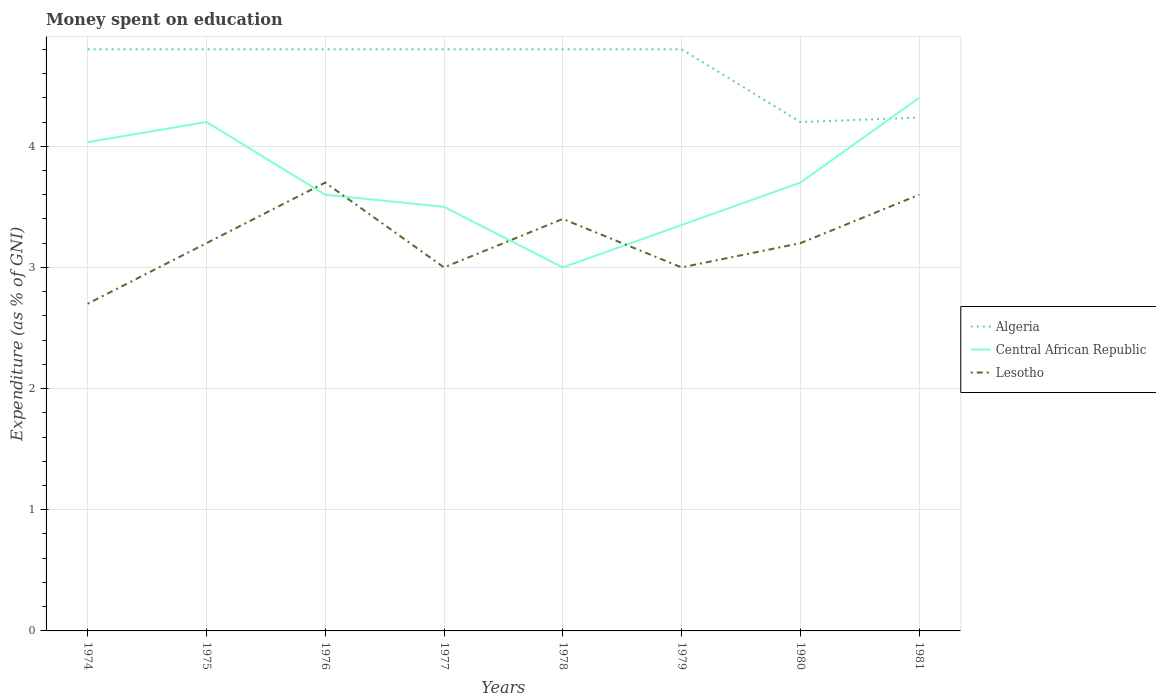How many different coloured lines are there?
Your answer should be compact. 3. Does the line corresponding to Central African Republic intersect with the line corresponding to Algeria?
Ensure brevity in your answer.  Yes. Is the number of lines equal to the number of legend labels?
Offer a terse response. Yes. Across all years, what is the maximum amount of money spent on education in Algeria?
Offer a terse response. 4.2. In which year was the amount of money spent on education in Lesotho maximum?
Keep it short and to the point. 1974. What is the total amount of money spent on education in Central African Republic in the graph?
Ensure brevity in your answer.  0.1. What is the difference between the highest and the second highest amount of money spent on education in Algeria?
Ensure brevity in your answer.  0.6. What is the difference between the highest and the lowest amount of money spent on education in Central African Republic?
Your answer should be very brief. 3. Is the amount of money spent on education in Algeria strictly greater than the amount of money spent on education in Central African Republic over the years?
Make the answer very short. No. Where does the legend appear in the graph?
Ensure brevity in your answer.  Center right. How many legend labels are there?
Give a very brief answer. 3. What is the title of the graph?
Provide a short and direct response. Money spent on education. What is the label or title of the Y-axis?
Offer a very short reply. Expenditure (as % of GNI). What is the Expenditure (as % of GNI) in Algeria in 1974?
Your response must be concise. 4.8. What is the Expenditure (as % of GNI) in Central African Republic in 1974?
Offer a very short reply. 4.03. What is the Expenditure (as % of GNI) in Lesotho in 1974?
Ensure brevity in your answer.  2.7. What is the Expenditure (as % of GNI) of Central African Republic in 1975?
Keep it short and to the point. 4.2. What is the Expenditure (as % of GNI) in Lesotho in 1975?
Give a very brief answer. 3.2. What is the Expenditure (as % of GNI) in Algeria in 1976?
Provide a short and direct response. 4.8. What is the Expenditure (as % of GNI) of Central African Republic in 1976?
Ensure brevity in your answer.  3.6. What is the Expenditure (as % of GNI) in Lesotho in 1976?
Offer a very short reply. 3.7. What is the Expenditure (as % of GNI) in Algeria in 1977?
Offer a very short reply. 4.8. What is the Expenditure (as % of GNI) in Lesotho in 1977?
Ensure brevity in your answer.  3. What is the Expenditure (as % of GNI) of Central African Republic in 1978?
Your response must be concise. 3. What is the Expenditure (as % of GNI) of Lesotho in 1978?
Make the answer very short. 3.4. What is the Expenditure (as % of GNI) in Central African Republic in 1979?
Offer a very short reply. 3.35. What is the Expenditure (as % of GNI) in Lesotho in 1979?
Ensure brevity in your answer.  3. What is the Expenditure (as % of GNI) of Central African Republic in 1980?
Your response must be concise. 3.7. What is the Expenditure (as % of GNI) in Algeria in 1981?
Your answer should be compact. 4.24. What is the Expenditure (as % of GNI) in Lesotho in 1981?
Keep it short and to the point. 3.6. Across all years, what is the maximum Expenditure (as % of GNI) in Lesotho?
Keep it short and to the point. 3.7. Across all years, what is the minimum Expenditure (as % of GNI) in Algeria?
Your answer should be compact. 4.2. Across all years, what is the minimum Expenditure (as % of GNI) in Lesotho?
Your answer should be very brief. 2.7. What is the total Expenditure (as % of GNI) in Algeria in the graph?
Provide a short and direct response. 37.24. What is the total Expenditure (as % of GNI) of Central African Republic in the graph?
Ensure brevity in your answer.  29.78. What is the total Expenditure (as % of GNI) of Lesotho in the graph?
Provide a succinct answer. 25.8. What is the difference between the Expenditure (as % of GNI) of Lesotho in 1974 and that in 1975?
Ensure brevity in your answer.  -0.5. What is the difference between the Expenditure (as % of GNI) of Algeria in 1974 and that in 1976?
Your answer should be very brief. 0. What is the difference between the Expenditure (as % of GNI) in Central African Republic in 1974 and that in 1976?
Your response must be concise. 0.43. What is the difference between the Expenditure (as % of GNI) in Algeria in 1974 and that in 1977?
Provide a succinct answer. 0. What is the difference between the Expenditure (as % of GNI) in Central African Republic in 1974 and that in 1977?
Your answer should be very brief. 0.53. What is the difference between the Expenditure (as % of GNI) in Lesotho in 1974 and that in 1977?
Provide a short and direct response. -0.3. What is the difference between the Expenditure (as % of GNI) of Lesotho in 1974 and that in 1978?
Ensure brevity in your answer.  -0.7. What is the difference between the Expenditure (as % of GNI) in Algeria in 1974 and that in 1979?
Provide a short and direct response. 0. What is the difference between the Expenditure (as % of GNI) of Central African Republic in 1974 and that in 1979?
Make the answer very short. 0.68. What is the difference between the Expenditure (as % of GNI) in Algeria in 1974 and that in 1980?
Make the answer very short. 0.6. What is the difference between the Expenditure (as % of GNI) in Algeria in 1974 and that in 1981?
Make the answer very short. 0.56. What is the difference between the Expenditure (as % of GNI) of Central African Republic in 1974 and that in 1981?
Provide a succinct answer. -0.37. What is the difference between the Expenditure (as % of GNI) of Algeria in 1975 and that in 1976?
Your response must be concise. 0. What is the difference between the Expenditure (as % of GNI) of Lesotho in 1975 and that in 1976?
Offer a very short reply. -0.5. What is the difference between the Expenditure (as % of GNI) of Algeria in 1975 and that in 1978?
Your response must be concise. 0. What is the difference between the Expenditure (as % of GNI) in Central African Republic in 1975 and that in 1978?
Keep it short and to the point. 1.2. What is the difference between the Expenditure (as % of GNI) of Lesotho in 1975 and that in 1979?
Make the answer very short. 0.2. What is the difference between the Expenditure (as % of GNI) of Algeria in 1975 and that in 1981?
Your answer should be very brief. 0.56. What is the difference between the Expenditure (as % of GNI) in Algeria in 1976 and that in 1977?
Ensure brevity in your answer.  0. What is the difference between the Expenditure (as % of GNI) in Central African Republic in 1976 and that in 1977?
Your answer should be very brief. 0.1. What is the difference between the Expenditure (as % of GNI) of Lesotho in 1976 and that in 1977?
Your answer should be compact. 0.7. What is the difference between the Expenditure (as % of GNI) in Algeria in 1976 and that in 1978?
Give a very brief answer. 0. What is the difference between the Expenditure (as % of GNI) of Algeria in 1976 and that in 1979?
Your answer should be compact. 0. What is the difference between the Expenditure (as % of GNI) in Central African Republic in 1976 and that in 1979?
Your answer should be compact. 0.25. What is the difference between the Expenditure (as % of GNI) of Lesotho in 1976 and that in 1979?
Your answer should be very brief. 0.7. What is the difference between the Expenditure (as % of GNI) of Lesotho in 1976 and that in 1980?
Provide a succinct answer. 0.5. What is the difference between the Expenditure (as % of GNI) of Algeria in 1976 and that in 1981?
Make the answer very short. 0.56. What is the difference between the Expenditure (as % of GNI) in Algeria in 1977 and that in 1978?
Make the answer very short. 0. What is the difference between the Expenditure (as % of GNI) of Central African Republic in 1977 and that in 1978?
Ensure brevity in your answer.  0.5. What is the difference between the Expenditure (as % of GNI) of Algeria in 1977 and that in 1979?
Offer a terse response. 0. What is the difference between the Expenditure (as % of GNI) of Central African Republic in 1977 and that in 1979?
Your answer should be very brief. 0.15. What is the difference between the Expenditure (as % of GNI) in Algeria in 1977 and that in 1980?
Offer a terse response. 0.6. What is the difference between the Expenditure (as % of GNI) of Algeria in 1977 and that in 1981?
Your response must be concise. 0.56. What is the difference between the Expenditure (as % of GNI) of Algeria in 1978 and that in 1979?
Provide a succinct answer. 0. What is the difference between the Expenditure (as % of GNI) of Central African Republic in 1978 and that in 1979?
Provide a short and direct response. -0.35. What is the difference between the Expenditure (as % of GNI) in Lesotho in 1978 and that in 1979?
Provide a short and direct response. 0.4. What is the difference between the Expenditure (as % of GNI) in Algeria in 1978 and that in 1980?
Provide a succinct answer. 0.6. What is the difference between the Expenditure (as % of GNI) in Central African Republic in 1978 and that in 1980?
Your answer should be very brief. -0.7. What is the difference between the Expenditure (as % of GNI) of Lesotho in 1978 and that in 1980?
Give a very brief answer. 0.2. What is the difference between the Expenditure (as % of GNI) in Algeria in 1978 and that in 1981?
Keep it short and to the point. 0.56. What is the difference between the Expenditure (as % of GNI) in Central African Republic in 1978 and that in 1981?
Keep it short and to the point. -1.4. What is the difference between the Expenditure (as % of GNI) in Lesotho in 1978 and that in 1981?
Give a very brief answer. -0.2. What is the difference between the Expenditure (as % of GNI) in Algeria in 1979 and that in 1980?
Make the answer very short. 0.6. What is the difference between the Expenditure (as % of GNI) in Central African Republic in 1979 and that in 1980?
Give a very brief answer. -0.35. What is the difference between the Expenditure (as % of GNI) in Algeria in 1979 and that in 1981?
Ensure brevity in your answer.  0.56. What is the difference between the Expenditure (as % of GNI) in Central African Republic in 1979 and that in 1981?
Your answer should be very brief. -1.05. What is the difference between the Expenditure (as % of GNI) of Lesotho in 1979 and that in 1981?
Offer a terse response. -0.6. What is the difference between the Expenditure (as % of GNI) of Algeria in 1980 and that in 1981?
Offer a terse response. -0.04. What is the difference between the Expenditure (as % of GNI) in Central African Republic in 1980 and that in 1981?
Give a very brief answer. -0.7. What is the difference between the Expenditure (as % of GNI) in Lesotho in 1980 and that in 1981?
Your response must be concise. -0.4. What is the difference between the Expenditure (as % of GNI) of Algeria in 1974 and the Expenditure (as % of GNI) of Lesotho in 1975?
Ensure brevity in your answer.  1.6. What is the difference between the Expenditure (as % of GNI) in Algeria in 1974 and the Expenditure (as % of GNI) in Central African Republic in 1977?
Make the answer very short. 1.3. What is the difference between the Expenditure (as % of GNI) of Central African Republic in 1974 and the Expenditure (as % of GNI) of Lesotho in 1977?
Your response must be concise. 1.03. What is the difference between the Expenditure (as % of GNI) in Central African Republic in 1974 and the Expenditure (as % of GNI) in Lesotho in 1978?
Your answer should be compact. 0.63. What is the difference between the Expenditure (as % of GNI) in Algeria in 1974 and the Expenditure (as % of GNI) in Central African Republic in 1979?
Provide a short and direct response. 1.45. What is the difference between the Expenditure (as % of GNI) in Algeria in 1974 and the Expenditure (as % of GNI) in Lesotho in 1979?
Your response must be concise. 1.8. What is the difference between the Expenditure (as % of GNI) in Algeria in 1974 and the Expenditure (as % of GNI) in Central African Republic in 1980?
Provide a succinct answer. 1.1. What is the difference between the Expenditure (as % of GNI) of Central African Republic in 1974 and the Expenditure (as % of GNI) of Lesotho in 1980?
Provide a short and direct response. 0.83. What is the difference between the Expenditure (as % of GNI) of Algeria in 1974 and the Expenditure (as % of GNI) of Central African Republic in 1981?
Offer a terse response. 0.4. What is the difference between the Expenditure (as % of GNI) in Central African Republic in 1974 and the Expenditure (as % of GNI) in Lesotho in 1981?
Your response must be concise. 0.43. What is the difference between the Expenditure (as % of GNI) in Algeria in 1975 and the Expenditure (as % of GNI) in Central African Republic in 1976?
Make the answer very short. 1.2. What is the difference between the Expenditure (as % of GNI) in Algeria in 1975 and the Expenditure (as % of GNI) in Central African Republic in 1977?
Keep it short and to the point. 1.3. What is the difference between the Expenditure (as % of GNI) in Central African Republic in 1975 and the Expenditure (as % of GNI) in Lesotho in 1977?
Your answer should be compact. 1.2. What is the difference between the Expenditure (as % of GNI) of Algeria in 1975 and the Expenditure (as % of GNI) of Central African Republic in 1979?
Your answer should be compact. 1.45. What is the difference between the Expenditure (as % of GNI) of Central African Republic in 1975 and the Expenditure (as % of GNI) of Lesotho in 1979?
Give a very brief answer. 1.2. What is the difference between the Expenditure (as % of GNI) in Algeria in 1975 and the Expenditure (as % of GNI) in Lesotho in 1980?
Offer a very short reply. 1.6. What is the difference between the Expenditure (as % of GNI) in Central African Republic in 1975 and the Expenditure (as % of GNI) in Lesotho in 1980?
Offer a very short reply. 1. What is the difference between the Expenditure (as % of GNI) of Algeria in 1975 and the Expenditure (as % of GNI) of Central African Republic in 1981?
Your answer should be very brief. 0.4. What is the difference between the Expenditure (as % of GNI) in Central African Republic in 1975 and the Expenditure (as % of GNI) in Lesotho in 1981?
Your response must be concise. 0.6. What is the difference between the Expenditure (as % of GNI) in Algeria in 1976 and the Expenditure (as % of GNI) in Lesotho in 1977?
Provide a short and direct response. 1.8. What is the difference between the Expenditure (as % of GNI) of Algeria in 1976 and the Expenditure (as % of GNI) of Lesotho in 1978?
Ensure brevity in your answer.  1.4. What is the difference between the Expenditure (as % of GNI) in Algeria in 1976 and the Expenditure (as % of GNI) in Central African Republic in 1979?
Give a very brief answer. 1.45. What is the difference between the Expenditure (as % of GNI) of Algeria in 1976 and the Expenditure (as % of GNI) of Central African Republic in 1980?
Make the answer very short. 1.1. What is the difference between the Expenditure (as % of GNI) of Algeria in 1976 and the Expenditure (as % of GNI) of Lesotho in 1980?
Keep it short and to the point. 1.6. What is the difference between the Expenditure (as % of GNI) of Algeria in 1976 and the Expenditure (as % of GNI) of Central African Republic in 1981?
Your answer should be compact. 0.4. What is the difference between the Expenditure (as % of GNI) in Central African Republic in 1976 and the Expenditure (as % of GNI) in Lesotho in 1981?
Give a very brief answer. 0. What is the difference between the Expenditure (as % of GNI) in Algeria in 1977 and the Expenditure (as % of GNI) in Lesotho in 1978?
Give a very brief answer. 1.4. What is the difference between the Expenditure (as % of GNI) of Central African Republic in 1977 and the Expenditure (as % of GNI) of Lesotho in 1978?
Keep it short and to the point. 0.1. What is the difference between the Expenditure (as % of GNI) in Algeria in 1977 and the Expenditure (as % of GNI) in Central African Republic in 1979?
Offer a very short reply. 1.45. What is the difference between the Expenditure (as % of GNI) in Algeria in 1977 and the Expenditure (as % of GNI) in Lesotho in 1979?
Provide a short and direct response. 1.8. What is the difference between the Expenditure (as % of GNI) in Central African Republic in 1977 and the Expenditure (as % of GNI) in Lesotho in 1981?
Offer a terse response. -0.1. What is the difference between the Expenditure (as % of GNI) of Algeria in 1978 and the Expenditure (as % of GNI) of Central African Republic in 1979?
Offer a terse response. 1.45. What is the difference between the Expenditure (as % of GNI) of Algeria in 1978 and the Expenditure (as % of GNI) of Lesotho in 1979?
Your response must be concise. 1.8. What is the difference between the Expenditure (as % of GNI) in Algeria in 1978 and the Expenditure (as % of GNI) in Lesotho in 1980?
Offer a terse response. 1.6. What is the difference between the Expenditure (as % of GNI) in Central African Republic in 1978 and the Expenditure (as % of GNI) in Lesotho in 1980?
Offer a very short reply. -0.2. What is the difference between the Expenditure (as % of GNI) in Central African Republic in 1978 and the Expenditure (as % of GNI) in Lesotho in 1981?
Your answer should be very brief. -0.6. What is the difference between the Expenditure (as % of GNI) of Algeria in 1979 and the Expenditure (as % of GNI) of Central African Republic in 1980?
Provide a short and direct response. 1.1. What is the difference between the Expenditure (as % of GNI) in Central African Republic in 1979 and the Expenditure (as % of GNI) in Lesotho in 1980?
Your answer should be compact. 0.15. What is the difference between the Expenditure (as % of GNI) of Algeria in 1979 and the Expenditure (as % of GNI) of Lesotho in 1981?
Make the answer very short. 1.2. What is the difference between the Expenditure (as % of GNI) in Central African Republic in 1979 and the Expenditure (as % of GNI) in Lesotho in 1981?
Offer a terse response. -0.25. What is the difference between the Expenditure (as % of GNI) of Algeria in 1980 and the Expenditure (as % of GNI) of Lesotho in 1981?
Your response must be concise. 0.6. What is the average Expenditure (as % of GNI) of Algeria per year?
Give a very brief answer. 4.65. What is the average Expenditure (as % of GNI) of Central African Republic per year?
Provide a short and direct response. 3.72. What is the average Expenditure (as % of GNI) in Lesotho per year?
Provide a succinct answer. 3.23. In the year 1974, what is the difference between the Expenditure (as % of GNI) of Algeria and Expenditure (as % of GNI) of Central African Republic?
Offer a terse response. 0.77. In the year 1974, what is the difference between the Expenditure (as % of GNI) in Algeria and Expenditure (as % of GNI) in Lesotho?
Your answer should be very brief. 2.1. In the year 1975, what is the difference between the Expenditure (as % of GNI) in Algeria and Expenditure (as % of GNI) in Central African Republic?
Offer a terse response. 0.6. In the year 1975, what is the difference between the Expenditure (as % of GNI) in Algeria and Expenditure (as % of GNI) in Lesotho?
Provide a short and direct response. 1.6. In the year 1975, what is the difference between the Expenditure (as % of GNI) in Central African Republic and Expenditure (as % of GNI) in Lesotho?
Make the answer very short. 1. In the year 1976, what is the difference between the Expenditure (as % of GNI) of Central African Republic and Expenditure (as % of GNI) of Lesotho?
Provide a succinct answer. -0.1. In the year 1977, what is the difference between the Expenditure (as % of GNI) of Algeria and Expenditure (as % of GNI) of Lesotho?
Your answer should be compact. 1.8. In the year 1978, what is the difference between the Expenditure (as % of GNI) of Algeria and Expenditure (as % of GNI) of Central African Republic?
Provide a succinct answer. 1.8. In the year 1978, what is the difference between the Expenditure (as % of GNI) of Algeria and Expenditure (as % of GNI) of Lesotho?
Provide a short and direct response. 1.4. In the year 1979, what is the difference between the Expenditure (as % of GNI) of Algeria and Expenditure (as % of GNI) of Central African Republic?
Ensure brevity in your answer.  1.45. In the year 1979, what is the difference between the Expenditure (as % of GNI) of Algeria and Expenditure (as % of GNI) of Lesotho?
Keep it short and to the point. 1.8. In the year 1980, what is the difference between the Expenditure (as % of GNI) in Algeria and Expenditure (as % of GNI) in Central African Republic?
Keep it short and to the point. 0.5. In the year 1980, what is the difference between the Expenditure (as % of GNI) in Algeria and Expenditure (as % of GNI) in Lesotho?
Make the answer very short. 1. In the year 1981, what is the difference between the Expenditure (as % of GNI) of Algeria and Expenditure (as % of GNI) of Central African Republic?
Keep it short and to the point. -0.16. In the year 1981, what is the difference between the Expenditure (as % of GNI) of Algeria and Expenditure (as % of GNI) of Lesotho?
Ensure brevity in your answer.  0.64. In the year 1981, what is the difference between the Expenditure (as % of GNI) in Central African Republic and Expenditure (as % of GNI) in Lesotho?
Keep it short and to the point. 0.8. What is the ratio of the Expenditure (as % of GNI) of Algeria in 1974 to that in 1975?
Provide a short and direct response. 1. What is the ratio of the Expenditure (as % of GNI) in Central African Republic in 1974 to that in 1975?
Ensure brevity in your answer.  0.96. What is the ratio of the Expenditure (as % of GNI) in Lesotho in 1974 to that in 1975?
Your response must be concise. 0.84. What is the ratio of the Expenditure (as % of GNI) of Algeria in 1974 to that in 1976?
Provide a succinct answer. 1. What is the ratio of the Expenditure (as % of GNI) in Central African Republic in 1974 to that in 1976?
Ensure brevity in your answer.  1.12. What is the ratio of the Expenditure (as % of GNI) in Lesotho in 1974 to that in 1976?
Provide a short and direct response. 0.73. What is the ratio of the Expenditure (as % of GNI) in Algeria in 1974 to that in 1977?
Offer a terse response. 1. What is the ratio of the Expenditure (as % of GNI) of Central African Republic in 1974 to that in 1977?
Provide a succinct answer. 1.15. What is the ratio of the Expenditure (as % of GNI) of Algeria in 1974 to that in 1978?
Your answer should be compact. 1. What is the ratio of the Expenditure (as % of GNI) of Central African Republic in 1974 to that in 1978?
Provide a short and direct response. 1.34. What is the ratio of the Expenditure (as % of GNI) of Lesotho in 1974 to that in 1978?
Ensure brevity in your answer.  0.79. What is the ratio of the Expenditure (as % of GNI) in Central African Republic in 1974 to that in 1979?
Provide a succinct answer. 1.2. What is the ratio of the Expenditure (as % of GNI) in Lesotho in 1974 to that in 1979?
Keep it short and to the point. 0.9. What is the ratio of the Expenditure (as % of GNI) of Central African Republic in 1974 to that in 1980?
Offer a terse response. 1.09. What is the ratio of the Expenditure (as % of GNI) of Lesotho in 1974 to that in 1980?
Provide a short and direct response. 0.84. What is the ratio of the Expenditure (as % of GNI) in Algeria in 1974 to that in 1981?
Your answer should be very brief. 1.13. What is the ratio of the Expenditure (as % of GNI) in Lesotho in 1974 to that in 1981?
Provide a succinct answer. 0.75. What is the ratio of the Expenditure (as % of GNI) in Algeria in 1975 to that in 1976?
Give a very brief answer. 1. What is the ratio of the Expenditure (as % of GNI) in Central African Republic in 1975 to that in 1976?
Provide a short and direct response. 1.17. What is the ratio of the Expenditure (as % of GNI) in Lesotho in 1975 to that in 1976?
Keep it short and to the point. 0.86. What is the ratio of the Expenditure (as % of GNI) in Algeria in 1975 to that in 1977?
Offer a very short reply. 1. What is the ratio of the Expenditure (as % of GNI) of Lesotho in 1975 to that in 1977?
Offer a very short reply. 1.07. What is the ratio of the Expenditure (as % of GNI) of Algeria in 1975 to that in 1979?
Provide a short and direct response. 1. What is the ratio of the Expenditure (as % of GNI) in Central African Republic in 1975 to that in 1979?
Provide a short and direct response. 1.25. What is the ratio of the Expenditure (as % of GNI) in Lesotho in 1975 to that in 1979?
Ensure brevity in your answer.  1.07. What is the ratio of the Expenditure (as % of GNI) in Central African Republic in 1975 to that in 1980?
Your answer should be compact. 1.14. What is the ratio of the Expenditure (as % of GNI) of Algeria in 1975 to that in 1981?
Your response must be concise. 1.13. What is the ratio of the Expenditure (as % of GNI) of Central African Republic in 1975 to that in 1981?
Provide a short and direct response. 0.95. What is the ratio of the Expenditure (as % of GNI) of Lesotho in 1975 to that in 1981?
Your answer should be very brief. 0.89. What is the ratio of the Expenditure (as % of GNI) of Algeria in 1976 to that in 1977?
Provide a short and direct response. 1. What is the ratio of the Expenditure (as % of GNI) in Central African Republic in 1976 to that in 1977?
Offer a very short reply. 1.03. What is the ratio of the Expenditure (as % of GNI) of Lesotho in 1976 to that in 1977?
Make the answer very short. 1.23. What is the ratio of the Expenditure (as % of GNI) of Algeria in 1976 to that in 1978?
Ensure brevity in your answer.  1. What is the ratio of the Expenditure (as % of GNI) of Lesotho in 1976 to that in 1978?
Give a very brief answer. 1.09. What is the ratio of the Expenditure (as % of GNI) of Algeria in 1976 to that in 1979?
Your answer should be very brief. 1. What is the ratio of the Expenditure (as % of GNI) of Central African Republic in 1976 to that in 1979?
Your response must be concise. 1.07. What is the ratio of the Expenditure (as % of GNI) of Lesotho in 1976 to that in 1979?
Your answer should be very brief. 1.23. What is the ratio of the Expenditure (as % of GNI) of Algeria in 1976 to that in 1980?
Your answer should be very brief. 1.14. What is the ratio of the Expenditure (as % of GNI) of Central African Republic in 1976 to that in 1980?
Provide a succinct answer. 0.97. What is the ratio of the Expenditure (as % of GNI) in Lesotho in 1976 to that in 1980?
Your answer should be compact. 1.16. What is the ratio of the Expenditure (as % of GNI) of Algeria in 1976 to that in 1981?
Offer a very short reply. 1.13. What is the ratio of the Expenditure (as % of GNI) in Central African Republic in 1976 to that in 1981?
Your answer should be very brief. 0.82. What is the ratio of the Expenditure (as % of GNI) of Lesotho in 1976 to that in 1981?
Make the answer very short. 1.03. What is the ratio of the Expenditure (as % of GNI) in Lesotho in 1977 to that in 1978?
Make the answer very short. 0.88. What is the ratio of the Expenditure (as % of GNI) in Central African Republic in 1977 to that in 1979?
Your answer should be compact. 1.04. What is the ratio of the Expenditure (as % of GNI) of Algeria in 1977 to that in 1980?
Your response must be concise. 1.14. What is the ratio of the Expenditure (as % of GNI) in Central African Republic in 1977 to that in 1980?
Provide a succinct answer. 0.95. What is the ratio of the Expenditure (as % of GNI) of Algeria in 1977 to that in 1981?
Ensure brevity in your answer.  1.13. What is the ratio of the Expenditure (as % of GNI) in Central African Republic in 1977 to that in 1981?
Make the answer very short. 0.8. What is the ratio of the Expenditure (as % of GNI) of Algeria in 1978 to that in 1979?
Your answer should be very brief. 1. What is the ratio of the Expenditure (as % of GNI) of Central African Republic in 1978 to that in 1979?
Provide a succinct answer. 0.9. What is the ratio of the Expenditure (as % of GNI) of Lesotho in 1978 to that in 1979?
Your answer should be compact. 1.13. What is the ratio of the Expenditure (as % of GNI) of Algeria in 1978 to that in 1980?
Keep it short and to the point. 1.14. What is the ratio of the Expenditure (as % of GNI) in Central African Republic in 1978 to that in 1980?
Offer a very short reply. 0.81. What is the ratio of the Expenditure (as % of GNI) of Algeria in 1978 to that in 1981?
Give a very brief answer. 1.13. What is the ratio of the Expenditure (as % of GNI) of Central African Republic in 1978 to that in 1981?
Provide a succinct answer. 0.68. What is the ratio of the Expenditure (as % of GNI) in Central African Republic in 1979 to that in 1980?
Your response must be concise. 0.91. What is the ratio of the Expenditure (as % of GNI) of Lesotho in 1979 to that in 1980?
Your answer should be compact. 0.94. What is the ratio of the Expenditure (as % of GNI) of Algeria in 1979 to that in 1981?
Offer a very short reply. 1.13. What is the ratio of the Expenditure (as % of GNI) in Central African Republic in 1979 to that in 1981?
Keep it short and to the point. 0.76. What is the ratio of the Expenditure (as % of GNI) in Lesotho in 1979 to that in 1981?
Offer a terse response. 0.83. What is the ratio of the Expenditure (as % of GNI) in Central African Republic in 1980 to that in 1981?
Offer a very short reply. 0.84. What is the difference between the highest and the second highest Expenditure (as % of GNI) of Central African Republic?
Make the answer very short. 0.2. What is the difference between the highest and the second highest Expenditure (as % of GNI) of Lesotho?
Provide a short and direct response. 0.1. What is the difference between the highest and the lowest Expenditure (as % of GNI) in Central African Republic?
Your answer should be very brief. 1.4. What is the difference between the highest and the lowest Expenditure (as % of GNI) of Lesotho?
Your response must be concise. 1. 